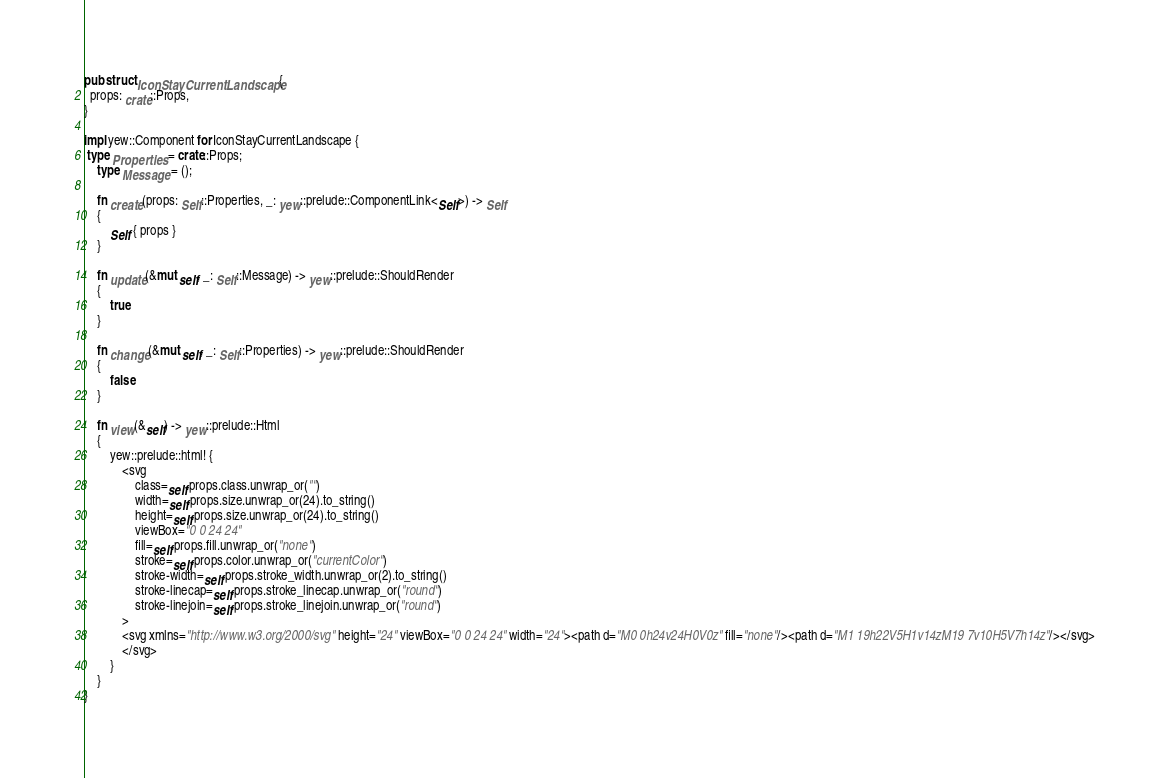Convert code to text. <code><loc_0><loc_0><loc_500><loc_500><_Rust_>
pub struct IconStayCurrentLandscape {
  props: crate::Props,
}

impl yew::Component for IconStayCurrentLandscape {
 type Properties = crate::Props;
    type Message = ();

    fn create(props: Self::Properties, _: yew::prelude::ComponentLink<Self>) -> Self
    {
        Self { props }
    }

    fn update(&mut self, _: Self::Message) -> yew::prelude::ShouldRender
    {
        true
    }

    fn change(&mut self, _: Self::Properties) -> yew::prelude::ShouldRender
    {
        false
    }

    fn view(&self) -> yew::prelude::Html
    {
        yew::prelude::html! {
            <svg
                class=self.props.class.unwrap_or("")
                width=self.props.size.unwrap_or(24).to_string()
                height=self.props.size.unwrap_or(24).to_string()
                viewBox="0 0 24 24"
                fill=self.props.fill.unwrap_or("none")
                stroke=self.props.color.unwrap_or("currentColor")
                stroke-width=self.props.stroke_width.unwrap_or(2).to_string()
                stroke-linecap=self.props.stroke_linecap.unwrap_or("round")
                stroke-linejoin=self.props.stroke_linejoin.unwrap_or("round")
            >
            <svg xmlns="http://www.w3.org/2000/svg" height="24" viewBox="0 0 24 24" width="24"><path d="M0 0h24v24H0V0z" fill="none"/><path d="M1 19h22V5H1v14zM19 7v10H5V7h14z"/></svg>
            </svg>
        }
    }
}


</code> 